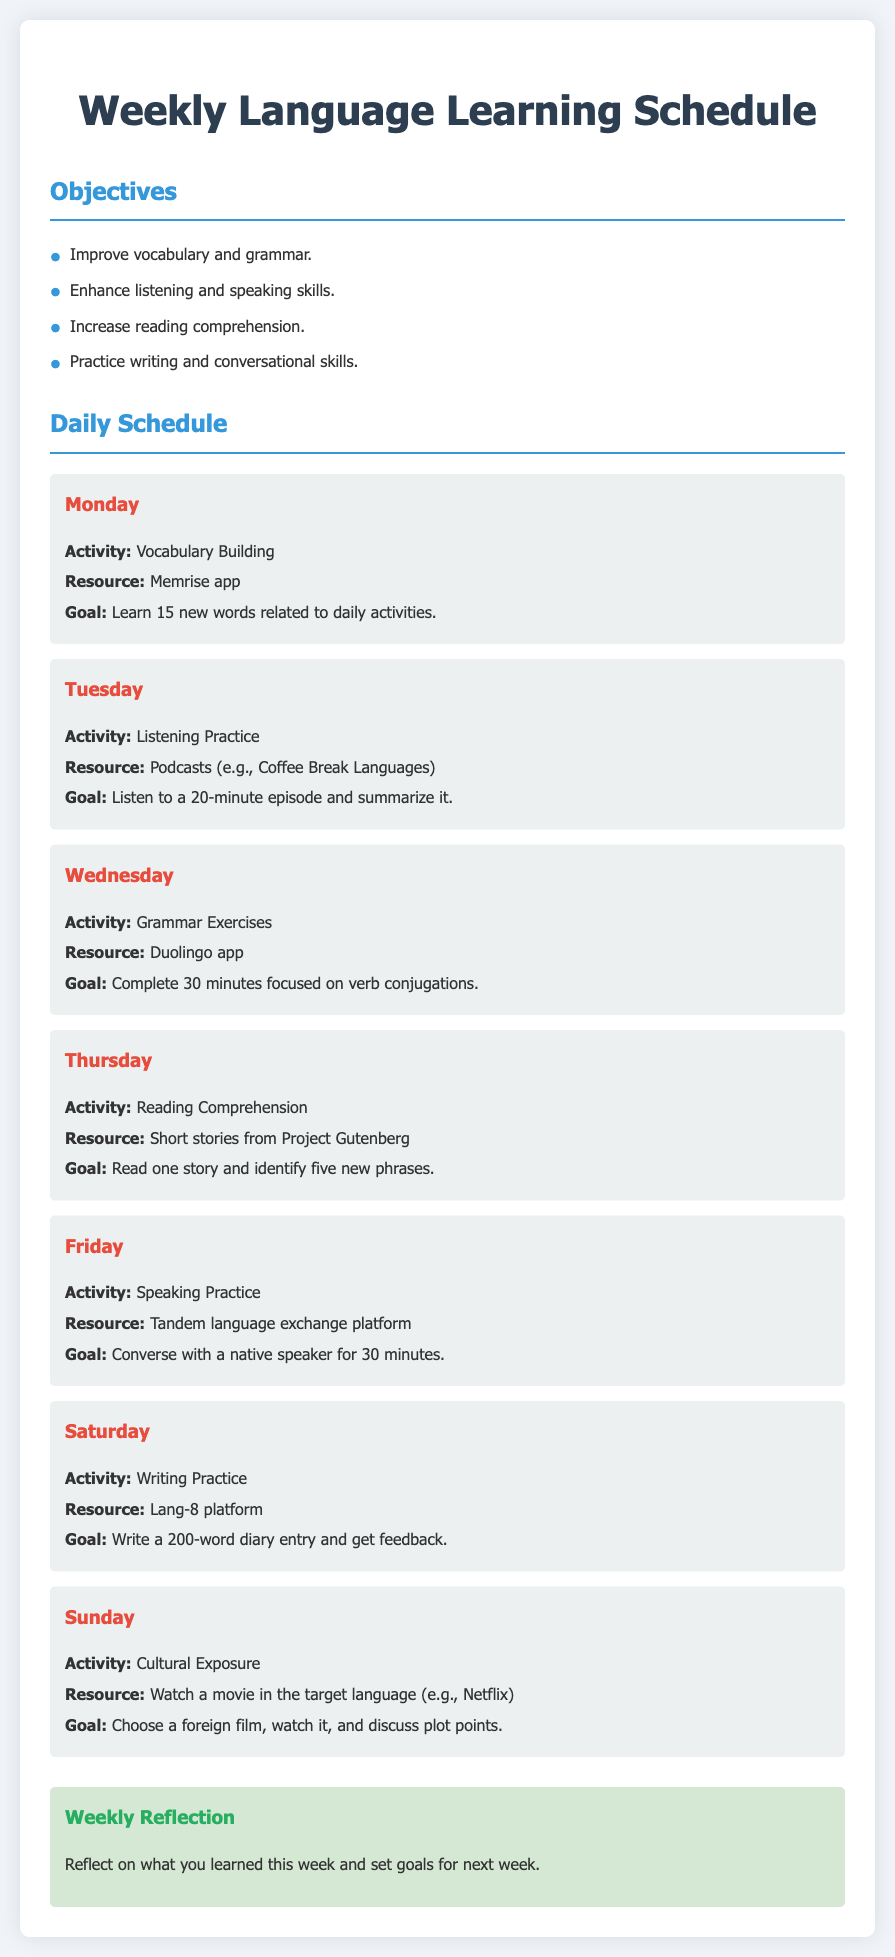what is the main goal for Monday? The main goal for Monday is to learn 15 new words related to daily activities.
Answer: learn 15 new words what activity is scheduled for Thursday? The document specifies that Thursday's activity is Reading Comprehension.
Answer: Reading Comprehension how many minutes should be spent on grammar exercises? The document states that 30 minutes should be spent on grammar exercises.
Answer: 30 minutes what is the resource for speaking practice? The resource for speaking practice is the Tandem language exchange platform.
Answer: Tandem language exchange platform what type of exposure is planned for Sunday? The document indicates that cultural exposure is planned for Sunday.
Answer: Cultural Exposure which app is used on Wednesday for grammar exercises? The specified app for grammar exercises is Duolingo.
Answer: Duolingo how many new phrases should be identified during Thursday's activity? The goal for Thursday's activity is to identify five new phrases.
Answer: five new phrases how long should the listening practice episode be on Tuesday? The listening practice episode on Tuesday should be 20 minutes long.
Answer: 20 minutes what should be reflected upon at the end of the week? The document mentions reflecting on what you learned this week and setting goals for next week.
Answer: what you learned this week and set goals for next week 